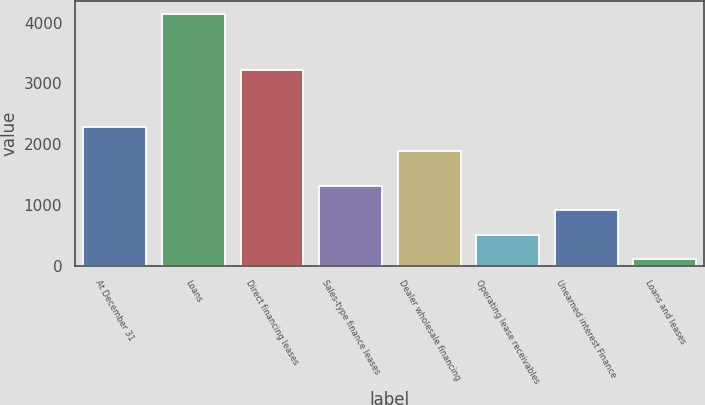Convert chart. <chart><loc_0><loc_0><loc_500><loc_500><bar_chart><fcel>At December 31<fcel>Loans<fcel>Direct financing leases<fcel>Sales-type finance leases<fcel>Dealer wholesale financing<fcel>Operating lease receivables<fcel>Unearned interest Finance<fcel>Loans and leases<nl><fcel>2285.19<fcel>4147.8<fcel>3211.7<fcel>1315.67<fcel>1880.6<fcel>506.49<fcel>911.08<fcel>101.9<nl></chart> 